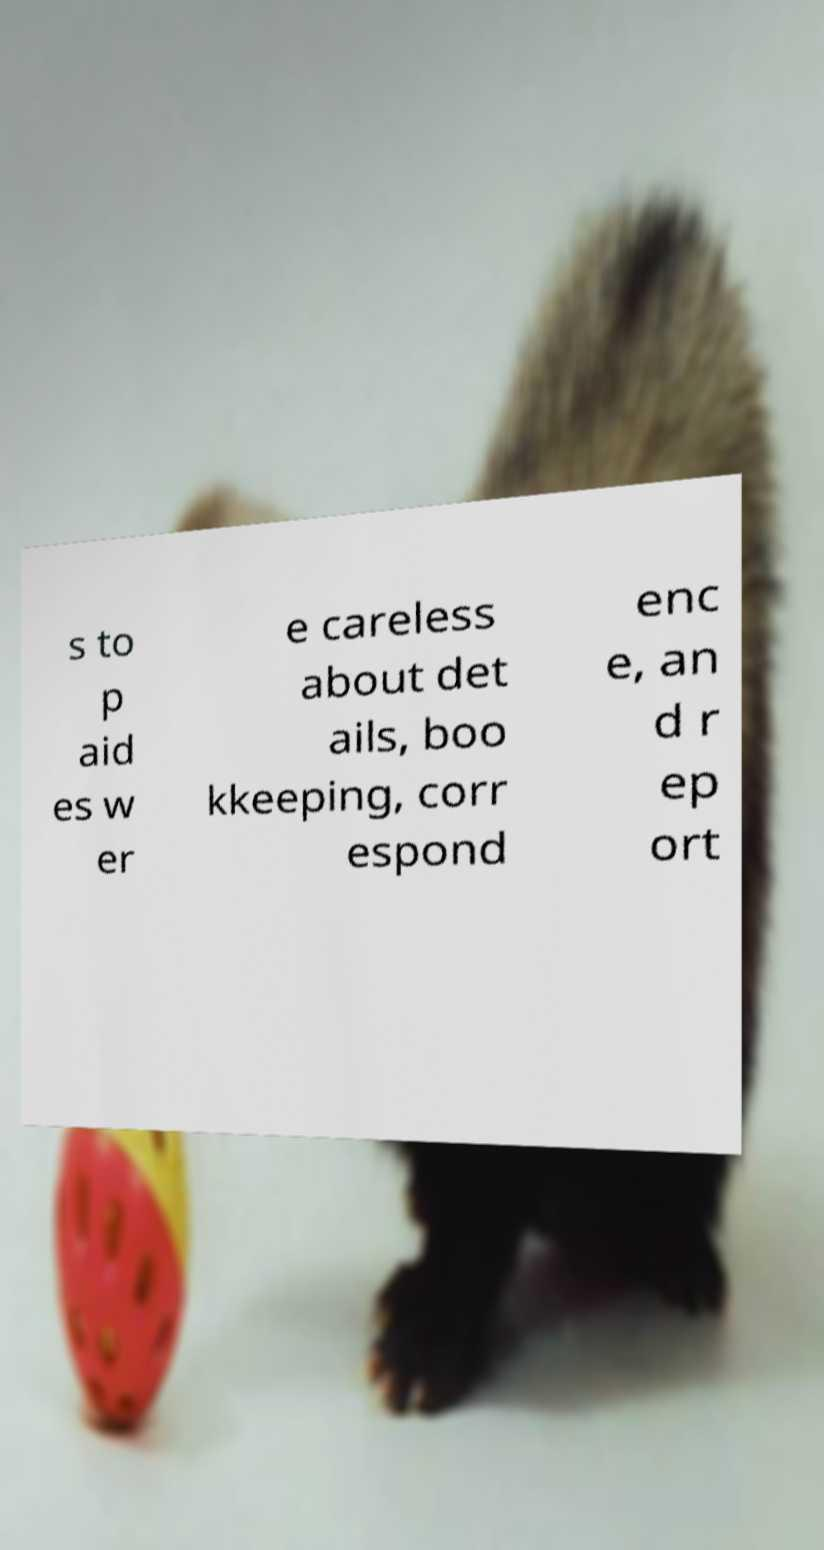For documentation purposes, I need the text within this image transcribed. Could you provide that? s to p aid es w er e careless about det ails, boo kkeeping, corr espond enc e, an d r ep ort 